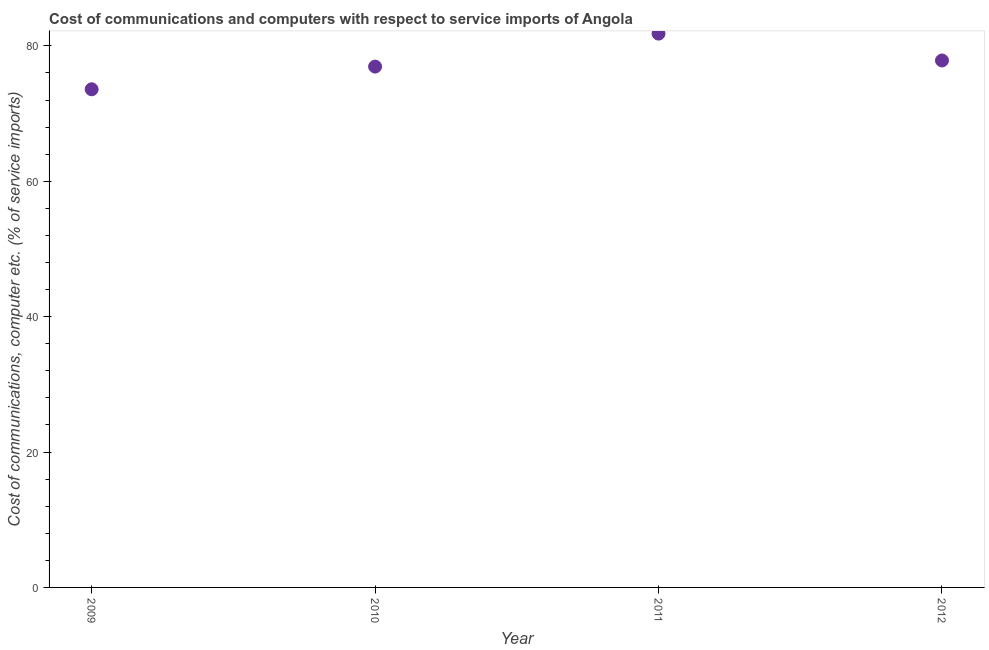What is the cost of communications and computer in 2009?
Ensure brevity in your answer.  73.59. Across all years, what is the maximum cost of communications and computer?
Give a very brief answer. 81.82. Across all years, what is the minimum cost of communications and computer?
Offer a terse response. 73.59. In which year was the cost of communications and computer minimum?
Your answer should be very brief. 2009. What is the sum of the cost of communications and computer?
Your answer should be very brief. 310.2. What is the difference between the cost of communications and computer in 2010 and 2012?
Offer a very short reply. -0.9. What is the average cost of communications and computer per year?
Ensure brevity in your answer.  77.55. What is the median cost of communications and computer?
Your answer should be compact. 77.39. In how many years, is the cost of communications and computer greater than 36 %?
Offer a terse response. 4. Do a majority of the years between 2011 and 2010 (inclusive) have cost of communications and computer greater than 12 %?
Provide a succinct answer. No. What is the ratio of the cost of communications and computer in 2010 to that in 2012?
Offer a very short reply. 0.99. Is the difference between the cost of communications and computer in 2010 and 2012 greater than the difference between any two years?
Ensure brevity in your answer.  No. What is the difference between the highest and the second highest cost of communications and computer?
Your response must be concise. 3.97. What is the difference between the highest and the lowest cost of communications and computer?
Your response must be concise. 8.22. In how many years, is the cost of communications and computer greater than the average cost of communications and computer taken over all years?
Keep it short and to the point. 2. Does the cost of communications and computer monotonically increase over the years?
Offer a terse response. No. How many years are there in the graph?
Offer a terse response. 4. What is the difference between two consecutive major ticks on the Y-axis?
Provide a short and direct response. 20. Are the values on the major ticks of Y-axis written in scientific E-notation?
Your answer should be compact. No. Does the graph contain grids?
Your response must be concise. No. What is the title of the graph?
Provide a short and direct response. Cost of communications and computers with respect to service imports of Angola. What is the label or title of the Y-axis?
Give a very brief answer. Cost of communications, computer etc. (% of service imports). What is the Cost of communications, computer etc. (% of service imports) in 2009?
Ensure brevity in your answer.  73.59. What is the Cost of communications, computer etc. (% of service imports) in 2010?
Ensure brevity in your answer.  76.94. What is the Cost of communications, computer etc. (% of service imports) in 2011?
Offer a very short reply. 81.82. What is the Cost of communications, computer etc. (% of service imports) in 2012?
Give a very brief answer. 77.85. What is the difference between the Cost of communications, computer etc. (% of service imports) in 2009 and 2010?
Ensure brevity in your answer.  -3.35. What is the difference between the Cost of communications, computer etc. (% of service imports) in 2009 and 2011?
Offer a very short reply. -8.22. What is the difference between the Cost of communications, computer etc. (% of service imports) in 2009 and 2012?
Offer a very short reply. -4.25. What is the difference between the Cost of communications, computer etc. (% of service imports) in 2010 and 2011?
Your response must be concise. -4.87. What is the difference between the Cost of communications, computer etc. (% of service imports) in 2010 and 2012?
Offer a very short reply. -0.9. What is the difference between the Cost of communications, computer etc. (% of service imports) in 2011 and 2012?
Offer a very short reply. 3.97. What is the ratio of the Cost of communications, computer etc. (% of service imports) in 2009 to that in 2010?
Provide a succinct answer. 0.96. What is the ratio of the Cost of communications, computer etc. (% of service imports) in 2009 to that in 2012?
Provide a short and direct response. 0.94. What is the ratio of the Cost of communications, computer etc. (% of service imports) in 2010 to that in 2012?
Offer a very short reply. 0.99. What is the ratio of the Cost of communications, computer etc. (% of service imports) in 2011 to that in 2012?
Keep it short and to the point. 1.05. 